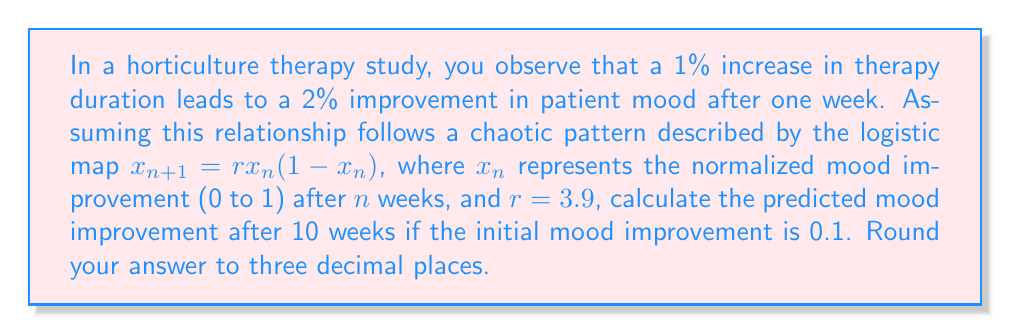Solve this math problem. To solve this problem, we'll use the logistic map equation iteratively:

1) Start with the given information:
   $x_0 = 0.1$ (initial mood improvement)
   $r = 3.9$ (growth rate)
   $n = 10$ (number of weeks)

2) Apply the logistic map equation for each week:
   $x_1 = 3.9 * 0.1 * (1-0.1) = 0.351$
   $x_2 = 3.9 * 0.351 * (1-0.351) = 0.8898$
   $x_3 = 3.9 * 0.8898 * (1-0.8898) = 0.3838$
   $x_4 = 3.9 * 0.3838 * (1-0.3838) = 0.9207$
   $x_5 = 3.9 * 0.9207 * (1-0.9207) = 0.2844$
   $x_6 = 3.9 * 0.2844 * (1-0.2844) = 0.7953$
   $x_7 = 3.9 * 0.7953 * (1-0.7953) = 0.6353$
   $x_8 = 3.9 * 0.6353 * (1-0.6353) = 0.9039$
   $x_9 = 3.9 * 0.9039 * (1-0.9039) = 0.3392$
   $x_{10} = 3.9 * 0.3392 * (1-0.3392) = 0.8754$

3) Round the final result to three decimal places: 0.875

This demonstrates the butterfly effect in horticulture therapy, where small initial changes can lead to significant and unpredictable long-term outcomes.
Answer: 0.875 